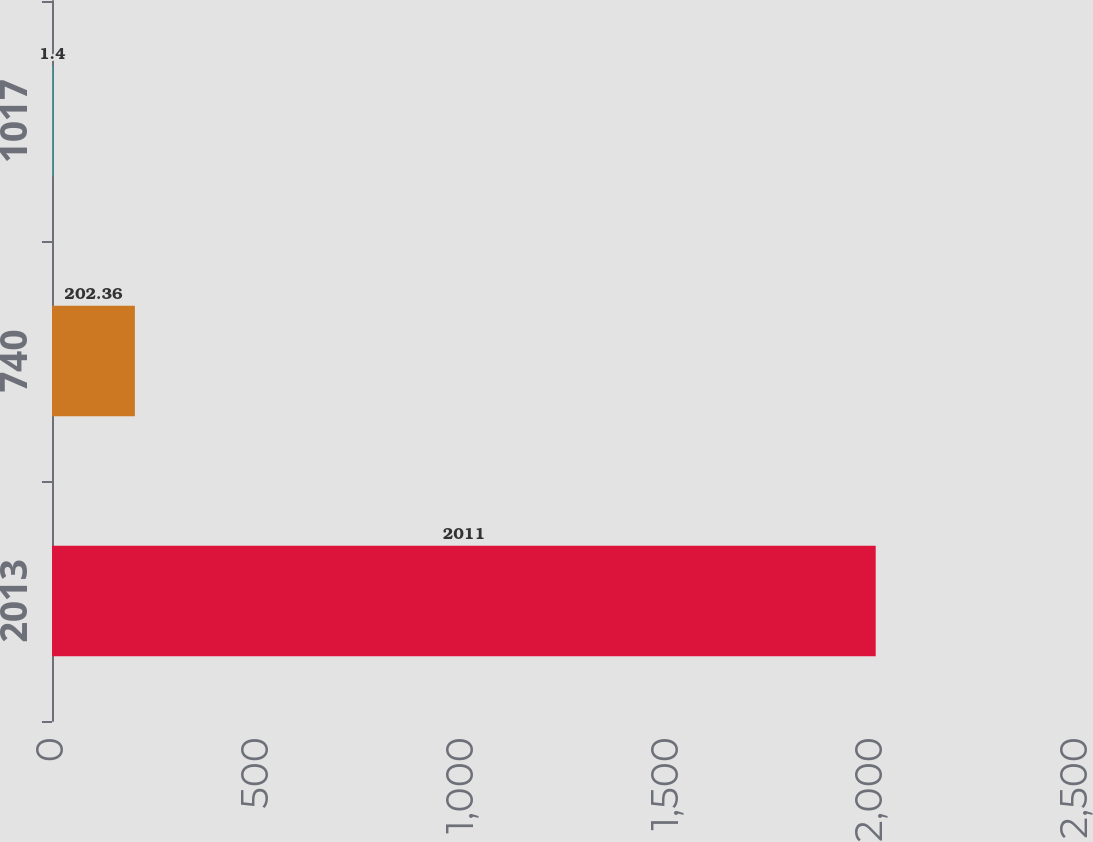Convert chart. <chart><loc_0><loc_0><loc_500><loc_500><bar_chart><fcel>2013<fcel>740<fcel>1017<nl><fcel>2011<fcel>202.36<fcel>1.4<nl></chart> 